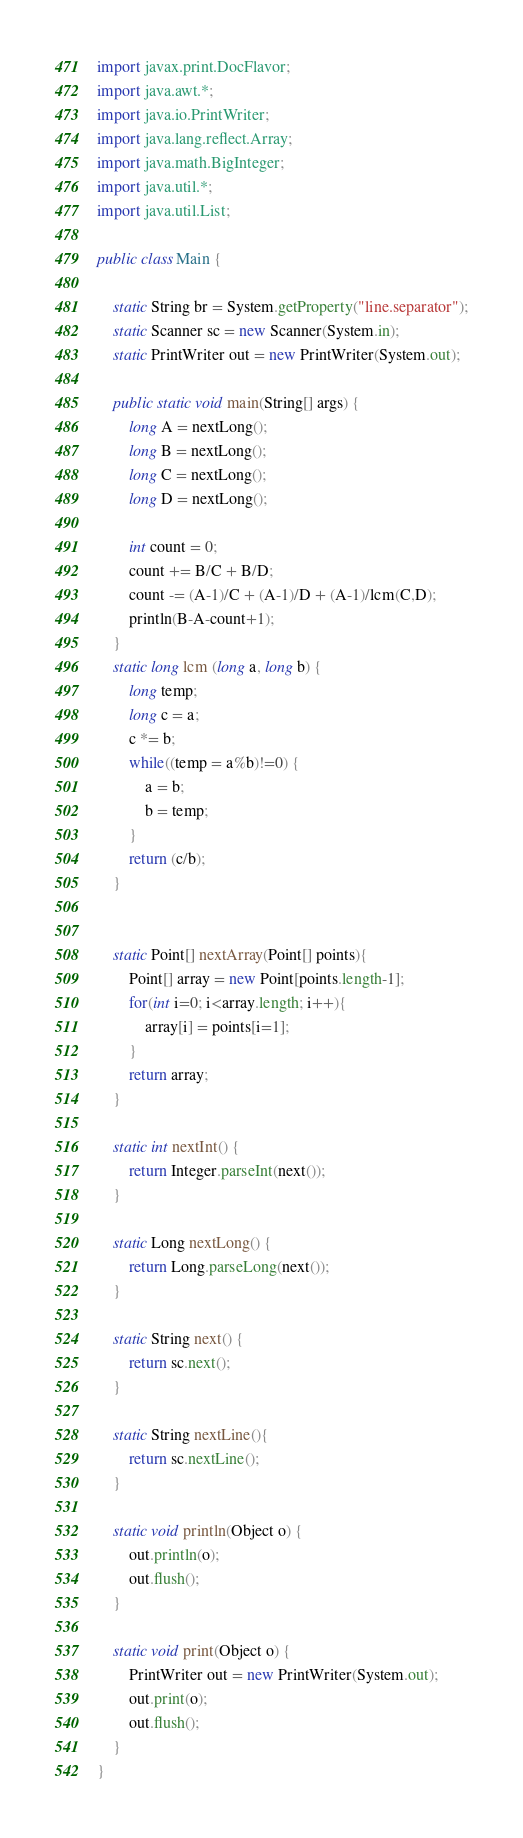Convert code to text. <code><loc_0><loc_0><loc_500><loc_500><_Java_>import javax.print.DocFlavor;
import java.awt.*;
import java.io.PrintWriter;
import java.lang.reflect.Array;
import java.math.BigInteger;
import java.util.*;
import java.util.List;

public class Main {

    static String br = System.getProperty("line.separator");
    static Scanner sc = new Scanner(System.in);
    static PrintWriter out = new PrintWriter(System.out);

    public static void main(String[] args) {
        long A = nextLong();
        long B = nextLong();
        long C = nextLong();
        long D = nextLong();

        int count = 0;
        count += B/C + B/D;
        count -= (A-1)/C + (A-1)/D + (A-1)/lcm(C,D);
        println(B-A-count+1);
    }
    static long lcm (long a, long b) {
        long temp;
        long c = a;
        c *= b;
        while((temp = a%b)!=0) {
            a = b;
            b = temp;
        }
        return (c/b);
    }


    static Point[] nextArray(Point[] points){
        Point[] array = new Point[points.length-1];
        for(int i=0; i<array.length; i++){
            array[i] = points[i=1];
        }
        return array;
    }

    static int nextInt() {
        return Integer.parseInt(next());
    }

    static Long nextLong() {
        return Long.parseLong(next());
    }

    static String next() {
        return sc.next();
    }

    static String nextLine(){
        return sc.nextLine();
    }

    static void println(Object o) {
        out.println(o);
        out.flush();
    }

    static void print(Object o) {
        PrintWriter out = new PrintWriter(System.out);
        out.print(o);
        out.flush();
    }
}
</code> 